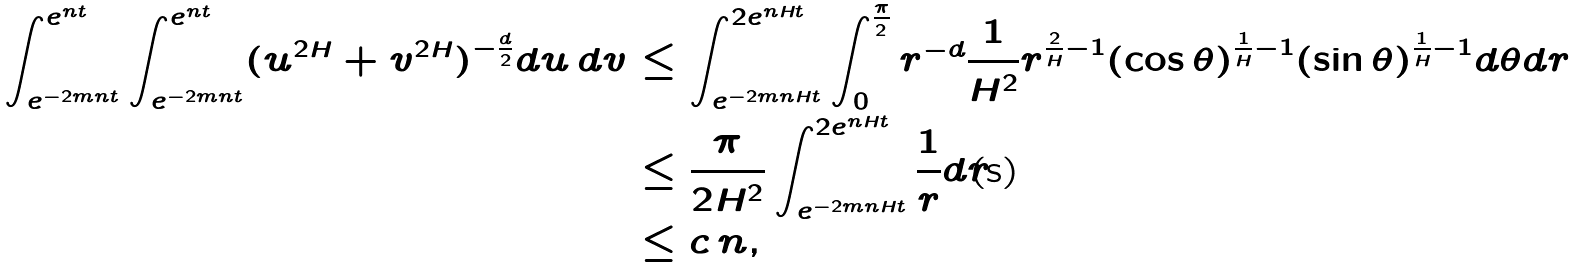Convert formula to latex. <formula><loc_0><loc_0><loc_500><loc_500>\int ^ { e ^ { n t } } _ { e ^ { - 2 m n t } } \int ^ { e ^ { n t } } _ { e ^ { - 2 m n t } } ( u ^ { 2 H } + v ^ { 2 H } ) ^ { - \frac { d } { 2 } } d u \, d v & \leq \int ^ { 2 e ^ { n H t } } _ { e ^ { - 2 m n H t } } \int ^ { \frac { \pi } { 2 } } _ { 0 } r ^ { - d } \frac { 1 } { H ^ { 2 } } r ^ { \frac { 2 } { H } - 1 } ( \cos \theta ) ^ { \frac { 1 } { H } - 1 } ( \sin \theta ) ^ { \frac { 1 } { H } - 1 } d \theta d r \\ & \leq \frac { \pi } { 2 H ^ { 2 } } \int ^ { 2 e ^ { n H t } } _ { e ^ { - 2 m n H t } } \frac { 1 } { r } d r \\ & \leq c \, n ,</formula> 